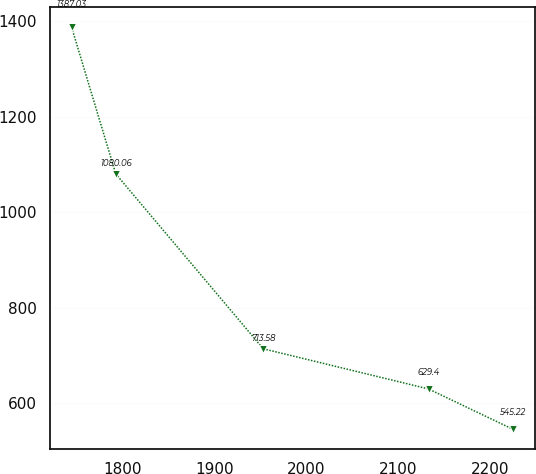Convert chart. <chart><loc_0><loc_0><loc_500><loc_500><line_chart><ecel><fcel>Unnamed: 1<nl><fcel>1744.52<fcel>1387.03<nl><fcel>1792.46<fcel>1080.06<nl><fcel>1952.8<fcel>713.58<nl><fcel>2132.53<fcel>629.4<nl><fcel>2223.95<fcel>545.22<nl></chart> 